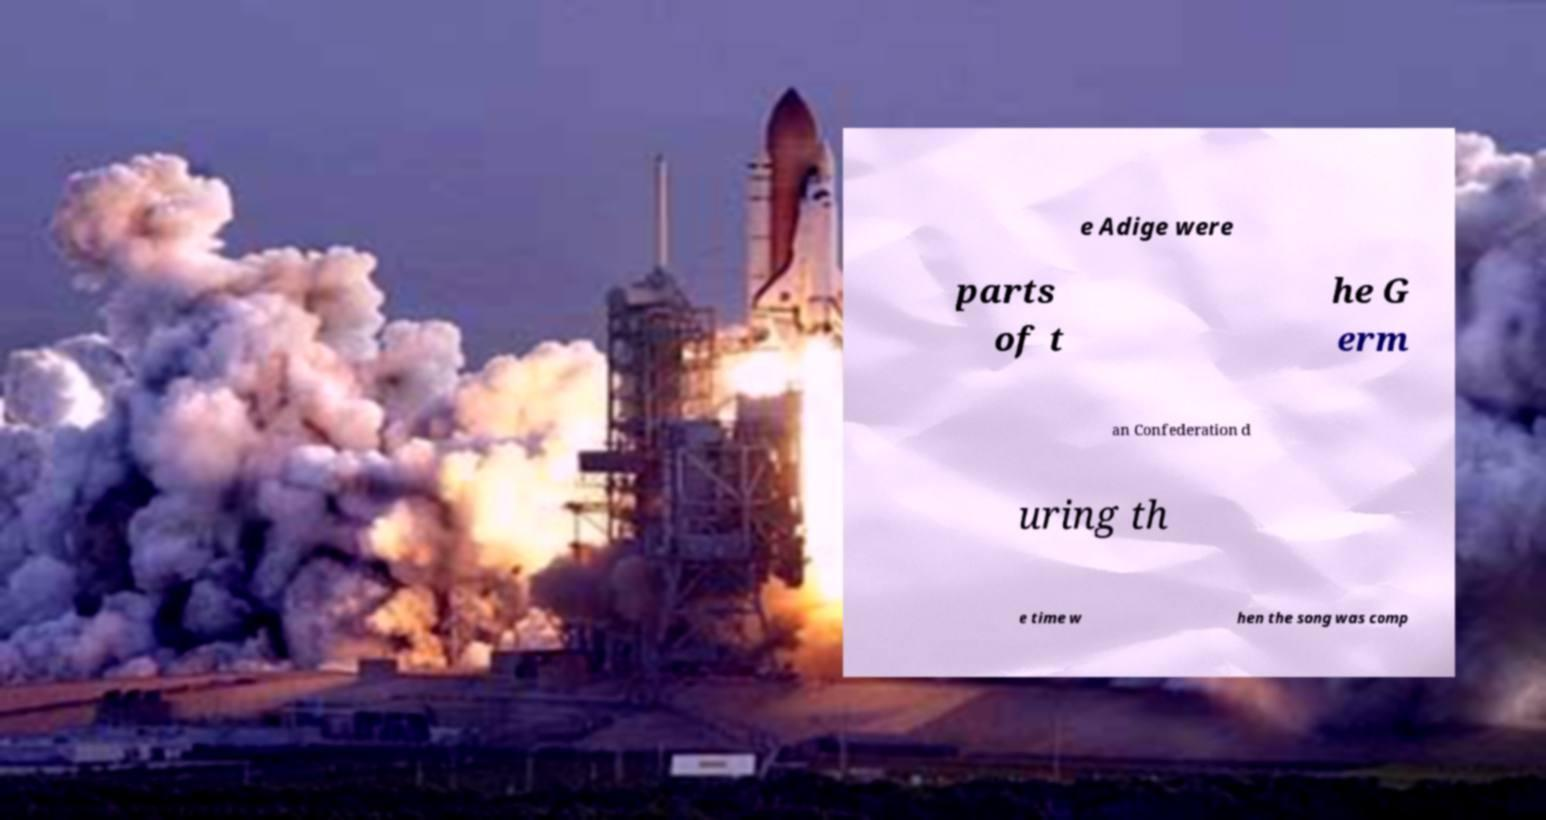Please read and relay the text visible in this image. What does it say? e Adige were parts of t he G erm an Confederation d uring th e time w hen the song was comp 